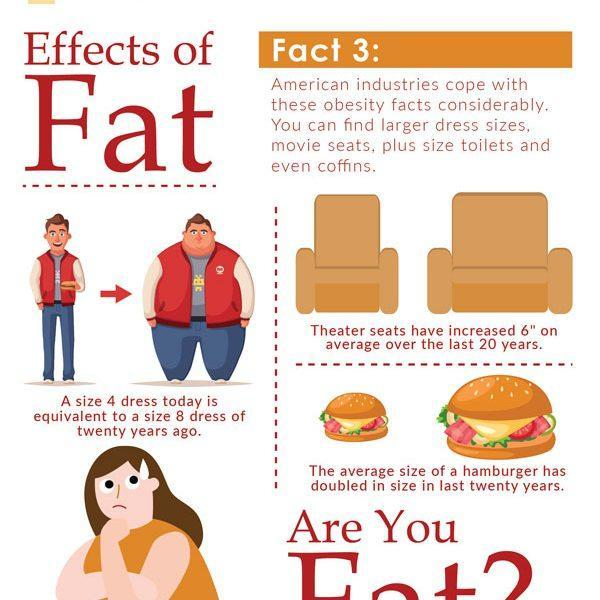How many seats are shown in the info graphic?
Answer the question with a short phrase. 2 